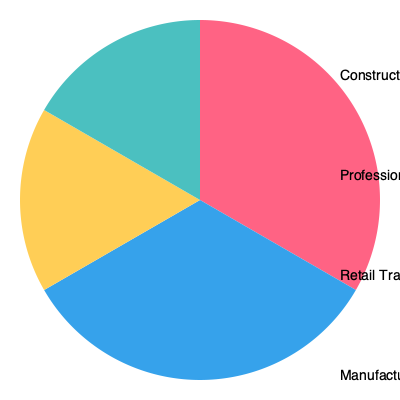Based on the pie chart showing the distribution of veteran-owned businesses across different industries, which sector represents the largest share, and what percentage of veteran-owned businesses does it account for? To answer this question, we need to analyze the pie chart and identify the largest sector:

1. The pie chart is divided into four sectors, each representing a different industry:
   - Construction
   - Professional Services
   - Retail Trade
   - Manufacturing

2. Each sector is labeled with its corresponding percentage:
   - Construction: 30%
   - Professional Services: 35%
   - Retail Trade: 25%
   - Manufacturing: 10%

3. To determine the largest share, we compare the percentages:
   - 35% > 30% > 25% > 10%

4. The largest percentage is 35%, which corresponds to the Professional Services sector.

Therefore, the Professional Services sector represents the largest share of veteran-owned businesses, accounting for 35% of the total.
Answer: Professional Services, 35% 